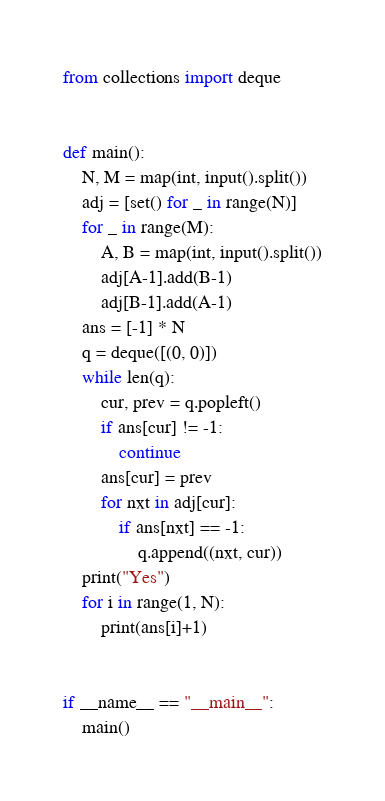<code> <loc_0><loc_0><loc_500><loc_500><_Python_>from collections import deque


def main():
    N, M = map(int, input().split())
    adj = [set() for _ in range(N)]
    for _ in range(M):
        A, B = map(int, input().split())
        adj[A-1].add(B-1)
        adj[B-1].add(A-1)
    ans = [-1] * N
    q = deque([(0, 0)])
    while len(q):
        cur, prev = q.popleft()
        if ans[cur] != -1:
            continue
        ans[cur] = prev
        for nxt in adj[cur]:
            if ans[nxt] == -1:
                q.append((nxt, cur))
    print("Yes")
    for i in range(1, N):
        print(ans[i]+1)


if __name__ == "__main__":
    main()
</code> 